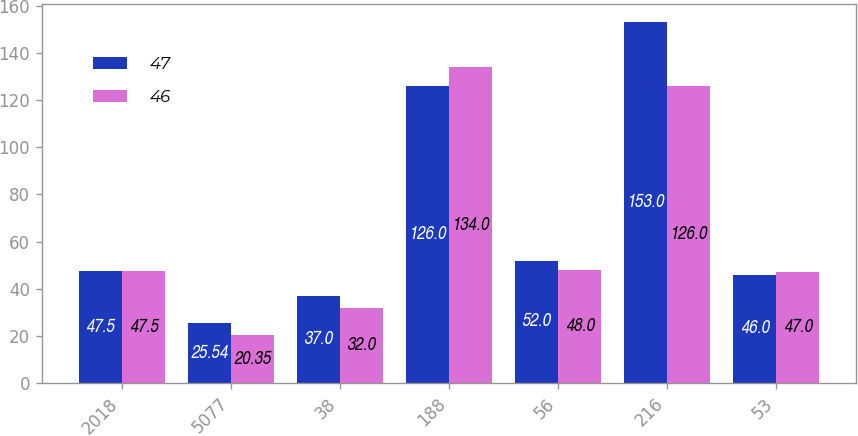Convert chart to OTSL. <chart><loc_0><loc_0><loc_500><loc_500><stacked_bar_chart><ecel><fcel>2018<fcel>5077<fcel>38<fcel>188<fcel>56<fcel>216<fcel>53<nl><fcel>47<fcel>47.5<fcel>25.54<fcel>37<fcel>126<fcel>52<fcel>153<fcel>46<nl><fcel>46<fcel>47.5<fcel>20.35<fcel>32<fcel>134<fcel>48<fcel>126<fcel>47<nl></chart> 